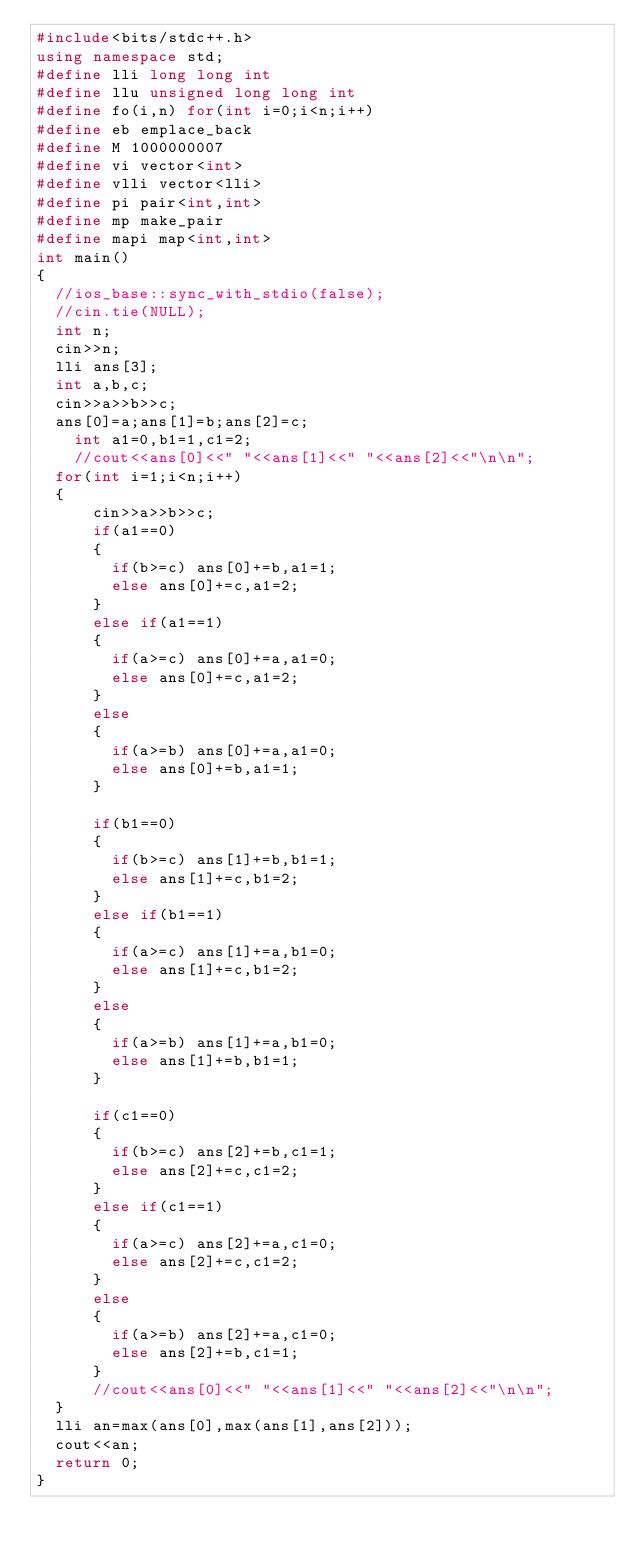<code> <loc_0><loc_0><loc_500><loc_500><_C++_>#include<bits/stdc++.h>
using namespace std;
#define lli long long int
#define llu unsigned long long int
#define fo(i,n) for(int i=0;i<n;i++)
#define eb emplace_back
#define M 1000000007
#define vi vector<int>
#define vlli vector<lli>
#define pi pair<int,int>
#define mp make_pair
#define mapi map<int,int>
int main()
{
  //ios_base::sync_with_stdio(false);
  //cin.tie(NULL);
	int n;
	cin>>n;
	lli ans[3];
	int a,b,c;
	cin>>a>>b>>c;
	ans[0]=a;ans[1]=b;ans[2]=c;
    int a1=0,b1=1,c1=2;
    //cout<<ans[0]<<" "<<ans[1]<<" "<<ans[2]<<"\n\n";
	for(int i=1;i<n;i++)
	{
			cin>>a>>b>>c;
			if(a1==0)
			{
				if(b>=c) ans[0]+=b,a1=1;
				else ans[0]+=c,a1=2;
			}
			else if(a1==1)
			{
				if(a>=c) ans[0]+=a,a1=0;
				else ans[0]+=c,a1=2;
			}
			else
			{
				if(a>=b) ans[0]+=a,a1=0;
				else ans[0]+=b,a1=1;
			}
		
			if(b1==0)
			{
				if(b>=c) ans[1]+=b,b1=1;
				else ans[1]+=c,b1=2;
			}
			else if(b1==1)
			{
				if(a>=c) ans[1]+=a,b1=0;
				else ans[1]+=c,b1=2;
			}
			else
			{
				if(a>=b) ans[1]+=a,b1=0;
				else ans[1]+=b,b1=1;
			}
			
			if(c1==0)
			{
				if(b>=c) ans[2]+=b,c1=1;
				else ans[2]+=c,c1=2;
			}
			else if(c1==1)
			{
				if(a>=c) ans[2]+=a,c1=0;
				else ans[2]+=c,c1=2;
			}
			else
			{
				if(a>=b) ans[2]+=a,c1=0;
				else ans[2]+=b,c1=1;
			}
		  //cout<<ans[0]<<" "<<ans[1]<<" "<<ans[2]<<"\n\n";
	}
	lli an=max(ans[0],max(ans[1],ans[2]));
	cout<<an;
	return 0;
}
</code> 